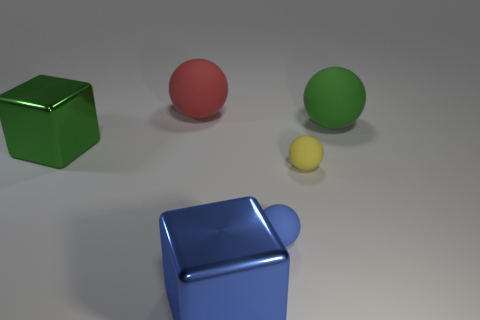Add 2 shiny objects. How many objects exist? 8 Subtract all spheres. How many objects are left? 2 Subtract 0 yellow blocks. How many objects are left? 6 Subtract all green spheres. Subtract all tiny blue spheres. How many objects are left? 4 Add 5 yellow spheres. How many yellow spheres are left? 6 Add 1 tiny blue matte objects. How many tiny blue matte objects exist? 2 